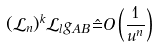Convert formula to latex. <formula><loc_0><loc_0><loc_500><loc_500>( \mathcal { L } _ { n } ) ^ { k } \mathcal { L } _ { l } g _ { A B } \, \hat { = } O \left ( \frac { 1 } { u ^ { n } } \right )</formula> 